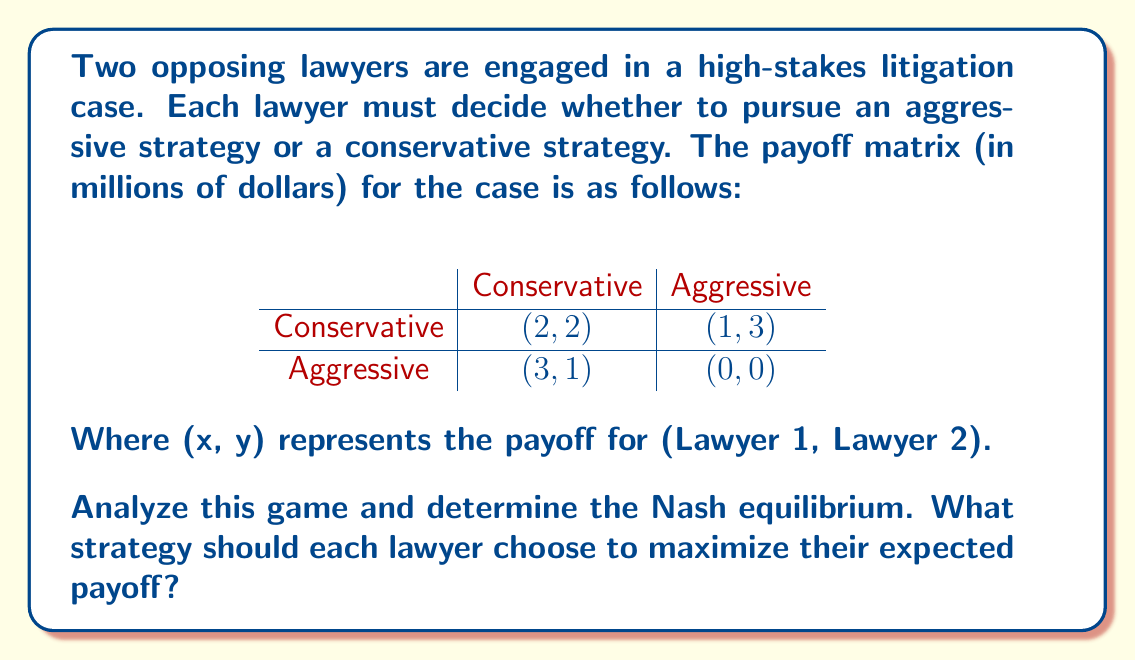Give your solution to this math problem. To solve this game theory problem and find the Nash equilibrium, we need to analyze each lawyer's best response to the other's strategy:

1. For Lawyer 1:
   - If Lawyer 2 chooses Conservative:
     Lawyer 1's payoff: Conservative = 2, Aggressive = 3
     Best response: Aggressive
   - If Lawyer 2 chooses Aggressive:
     Lawyer 1's payoff: Conservative = 1, Aggressive = 0
     Best response: Conservative

2. For Lawyer 2:
   - If Lawyer 1 chooses Conservative:
     Lawyer 2's payoff: Conservative = 2, Aggressive = 3
     Best response: Aggressive
   - If Lawyer 1 chooses Aggressive:
     Lawyer 2's payoff: Conservative = 1, Aggressive = 0
     Best response: Conservative

A Nash equilibrium occurs when each player's strategy is the best response to the other player's strategy. From our analysis, we can see that there is no pure strategy Nash equilibrium, as there's no combination where both lawyers are simultaneously playing their best response.

In this case, we need to look for a mixed strategy Nash equilibrium. Let's define:
- $p$ = probability of Lawyer 1 choosing Conservative
- $q$ = probability of Lawyer 2 choosing Conservative

For a mixed strategy equilibrium, each lawyer should be indifferent between their two strategies. We can set up two equations:

For Lawyer 1: $2q + 1(1-q) = 3q + 0(1-q)$
For Lawyer 2: $2p + 1(1-p) = 3p + 0(1-p)$

Solving these equations:
$2q + 1 - q = 3q$
$q + 1 = 3q$
$1 = 2q$
$q = \frac{1}{2}$

Similarly, $p = \frac{1}{2}$

Therefore, in the Nash equilibrium, each lawyer should choose the Conservative strategy with probability $\frac{1}{2}$ and the Aggressive strategy with probability $\frac{1}{2}$.

The expected payoff for each lawyer in this equilibrium is:

$E = \frac{1}{2} \cdot \frac{1}{2} \cdot 2 + \frac{1}{2} \cdot \frac{1}{2} \cdot 1 + \frac{1}{2} \cdot \frac{1}{2} \cdot 3 + \frac{1}{2} \cdot \frac{1}{2} \cdot 0 = \frac{3}{2} = 1.5$
Answer: The Nash equilibrium is a mixed strategy where each lawyer chooses the Conservative strategy with probability $\frac{1}{2}$ and the Aggressive strategy with probability $\frac{1}{2}$. The expected payoff for each lawyer in this equilibrium is $1.5$ million dollars. 